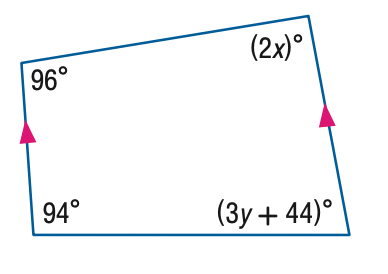Answer the mathemtical geometry problem and directly provide the correct option letter.
Question: Find the value of the variable y in the figure.
Choices: A: 14 B: 16.7 C: 42 D: 86 A 